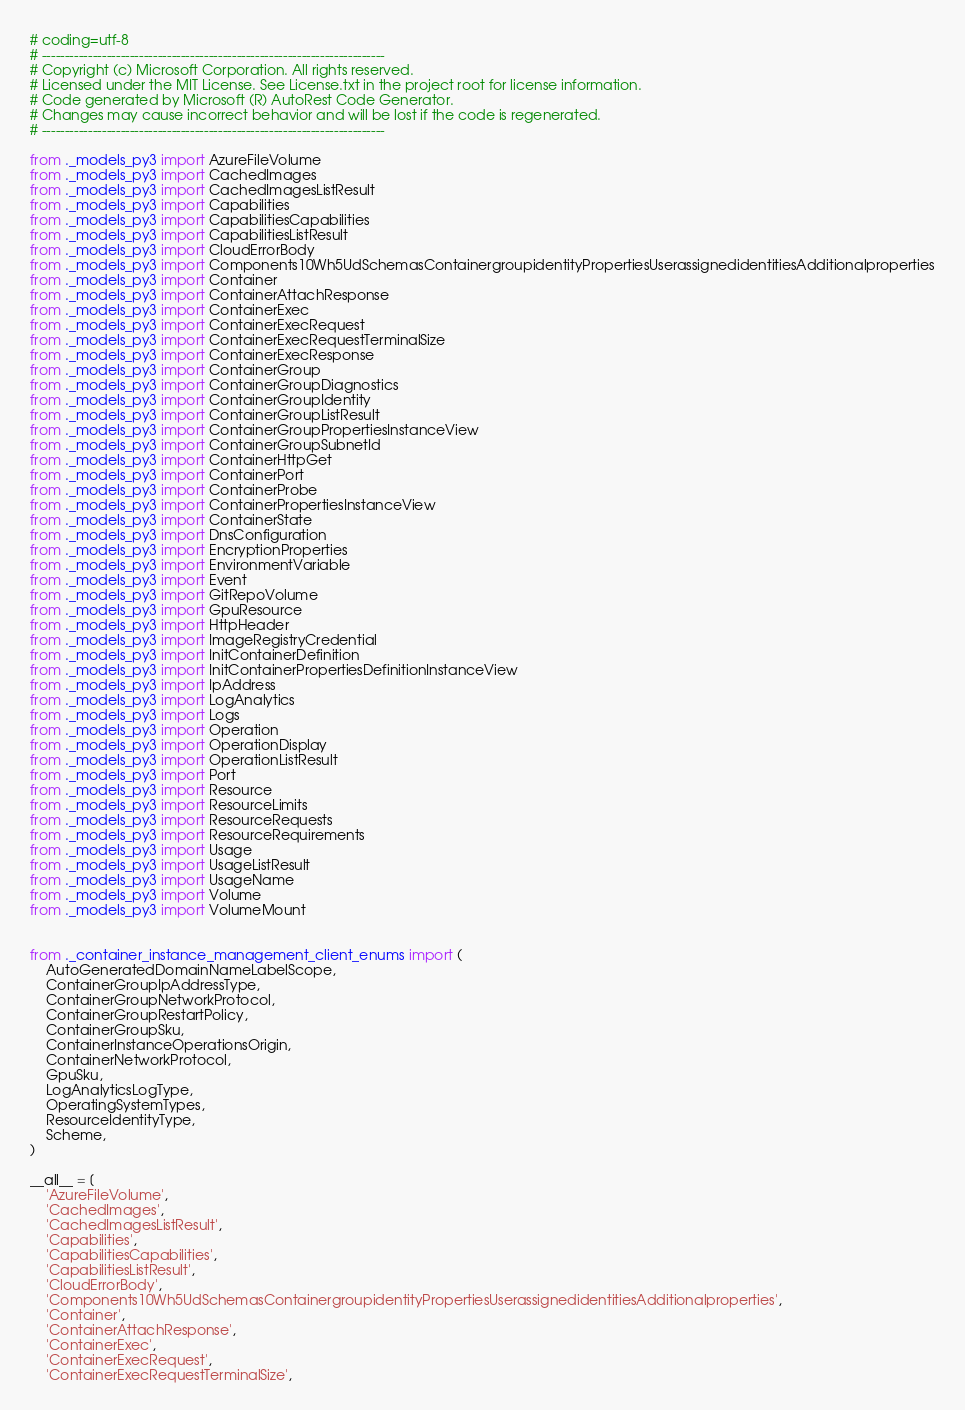<code> <loc_0><loc_0><loc_500><loc_500><_Python_># coding=utf-8
# --------------------------------------------------------------------------
# Copyright (c) Microsoft Corporation. All rights reserved.
# Licensed under the MIT License. See License.txt in the project root for license information.
# Code generated by Microsoft (R) AutoRest Code Generator.
# Changes may cause incorrect behavior and will be lost if the code is regenerated.
# --------------------------------------------------------------------------

from ._models_py3 import AzureFileVolume
from ._models_py3 import CachedImages
from ._models_py3 import CachedImagesListResult
from ._models_py3 import Capabilities
from ._models_py3 import CapabilitiesCapabilities
from ._models_py3 import CapabilitiesListResult
from ._models_py3 import CloudErrorBody
from ._models_py3 import Components10Wh5UdSchemasContainergroupidentityPropertiesUserassignedidentitiesAdditionalproperties
from ._models_py3 import Container
from ._models_py3 import ContainerAttachResponse
from ._models_py3 import ContainerExec
from ._models_py3 import ContainerExecRequest
from ._models_py3 import ContainerExecRequestTerminalSize
from ._models_py3 import ContainerExecResponse
from ._models_py3 import ContainerGroup
from ._models_py3 import ContainerGroupDiagnostics
from ._models_py3 import ContainerGroupIdentity
from ._models_py3 import ContainerGroupListResult
from ._models_py3 import ContainerGroupPropertiesInstanceView
from ._models_py3 import ContainerGroupSubnetId
from ._models_py3 import ContainerHttpGet
from ._models_py3 import ContainerPort
from ._models_py3 import ContainerProbe
from ._models_py3 import ContainerPropertiesInstanceView
from ._models_py3 import ContainerState
from ._models_py3 import DnsConfiguration
from ._models_py3 import EncryptionProperties
from ._models_py3 import EnvironmentVariable
from ._models_py3 import Event
from ._models_py3 import GitRepoVolume
from ._models_py3 import GpuResource
from ._models_py3 import HttpHeader
from ._models_py3 import ImageRegistryCredential
from ._models_py3 import InitContainerDefinition
from ._models_py3 import InitContainerPropertiesDefinitionInstanceView
from ._models_py3 import IpAddress
from ._models_py3 import LogAnalytics
from ._models_py3 import Logs
from ._models_py3 import Operation
from ._models_py3 import OperationDisplay
from ._models_py3 import OperationListResult
from ._models_py3 import Port
from ._models_py3 import Resource
from ._models_py3 import ResourceLimits
from ._models_py3 import ResourceRequests
from ._models_py3 import ResourceRequirements
from ._models_py3 import Usage
from ._models_py3 import UsageListResult
from ._models_py3 import UsageName
from ._models_py3 import Volume
from ._models_py3 import VolumeMount


from ._container_instance_management_client_enums import (
    AutoGeneratedDomainNameLabelScope,
    ContainerGroupIpAddressType,
    ContainerGroupNetworkProtocol,
    ContainerGroupRestartPolicy,
    ContainerGroupSku,
    ContainerInstanceOperationsOrigin,
    ContainerNetworkProtocol,
    GpuSku,
    LogAnalyticsLogType,
    OperatingSystemTypes,
    ResourceIdentityType,
    Scheme,
)

__all__ = [
    'AzureFileVolume',
    'CachedImages',
    'CachedImagesListResult',
    'Capabilities',
    'CapabilitiesCapabilities',
    'CapabilitiesListResult',
    'CloudErrorBody',
    'Components10Wh5UdSchemasContainergroupidentityPropertiesUserassignedidentitiesAdditionalproperties',
    'Container',
    'ContainerAttachResponse',
    'ContainerExec',
    'ContainerExecRequest',
    'ContainerExecRequestTerminalSize',</code> 